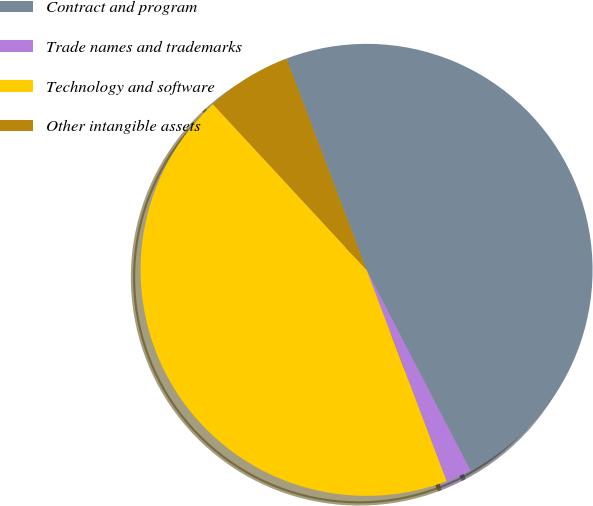<chart> <loc_0><loc_0><loc_500><loc_500><pie_chart><fcel>Contract and program<fcel>Trade names and trademarks<fcel>Technology and software<fcel>Other intangible assets<nl><fcel>48.16%<fcel>1.84%<fcel>43.87%<fcel>6.13%<nl></chart> 